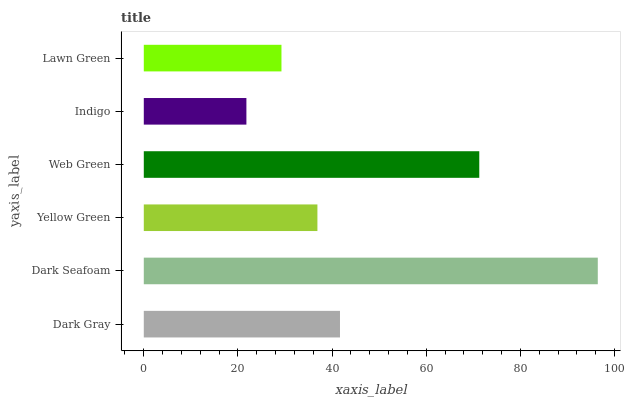Is Indigo the minimum?
Answer yes or no. Yes. Is Dark Seafoam the maximum?
Answer yes or no. Yes. Is Yellow Green the minimum?
Answer yes or no. No. Is Yellow Green the maximum?
Answer yes or no. No. Is Dark Seafoam greater than Yellow Green?
Answer yes or no. Yes. Is Yellow Green less than Dark Seafoam?
Answer yes or no. Yes. Is Yellow Green greater than Dark Seafoam?
Answer yes or no. No. Is Dark Seafoam less than Yellow Green?
Answer yes or no. No. Is Dark Gray the high median?
Answer yes or no. Yes. Is Yellow Green the low median?
Answer yes or no. Yes. Is Web Green the high median?
Answer yes or no. No. Is Lawn Green the low median?
Answer yes or no. No. 